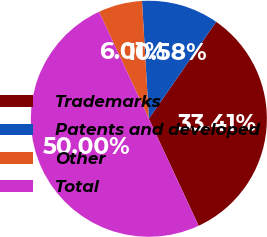<chart> <loc_0><loc_0><loc_500><loc_500><pie_chart><fcel>Trademarks<fcel>Patents and developed<fcel>Other<fcel>Total<nl><fcel>33.41%<fcel>10.58%<fcel>6.01%<fcel>50.0%<nl></chart> 